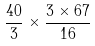Convert formula to latex. <formula><loc_0><loc_0><loc_500><loc_500>\frac { 4 0 } { 3 } \times \frac { 3 \times 6 7 } { 1 6 }</formula> 